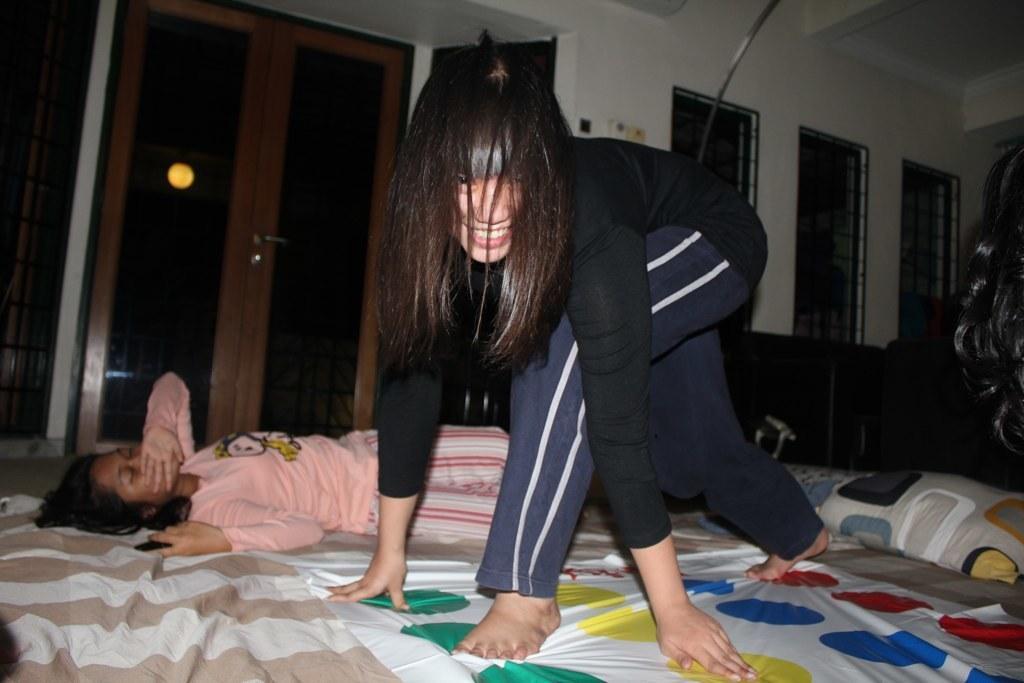In one or two sentences, can you explain what this image depicts? Here we can see two persons and she is smiling. This is cloth and there are pillows. In the background we can see a door, light, windows, and wall. 